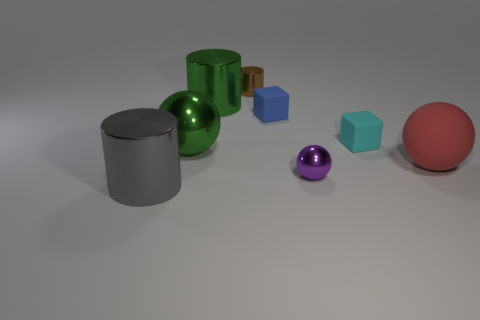Does the large gray object have the same material as the big red thing?
Your answer should be compact. No. What number of objects are green matte cylinders or gray cylinders?
Keep it short and to the point. 1. The blue cube is what size?
Make the answer very short. Small. Is the number of small brown things less than the number of big metal cylinders?
Make the answer very short. Yes. How many small matte objects have the same color as the small metal sphere?
Your answer should be compact. 0. There is a tiny matte block to the right of the small blue cube; is its color the same as the small shiny sphere?
Your response must be concise. No. What is the shape of the object to the left of the green metallic sphere?
Your answer should be very brief. Cylinder. Is there a cyan block that is left of the big metal cylinder that is behind the gray object?
Your answer should be very brief. No. How many other balls are made of the same material as the purple sphere?
Offer a terse response. 1. There is a cylinder that is right of the big metallic cylinder that is to the right of the metal cylinder that is in front of the red thing; what size is it?
Provide a succinct answer. Small. 